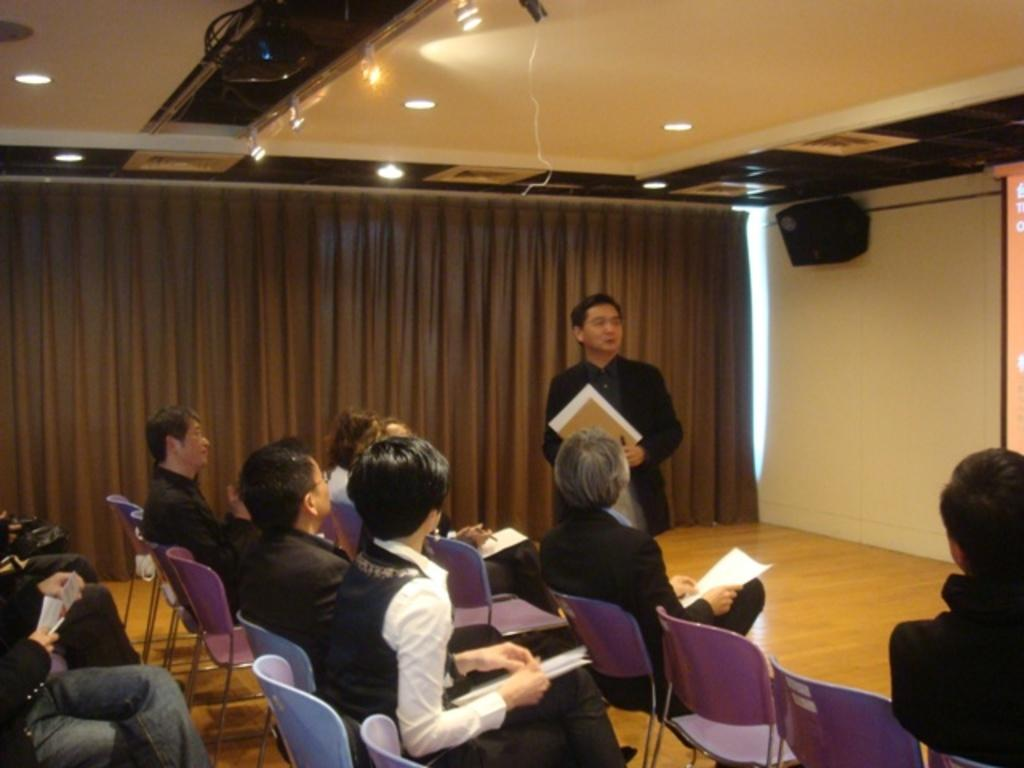What are the people in the image doing? The people in the image are sitting on chairs. What is the man in the image doing? The man is standing and holding a paper. What can be seen in the background of the image? There is a curtain and a speaker in the background of the image. What other objects are visible in the image? There are lights and a projector visible in the image. What is the aftermath of the summer agreement in the image? There is no mention of an agreement or summer in the image, so it is not possible to answer this question. 